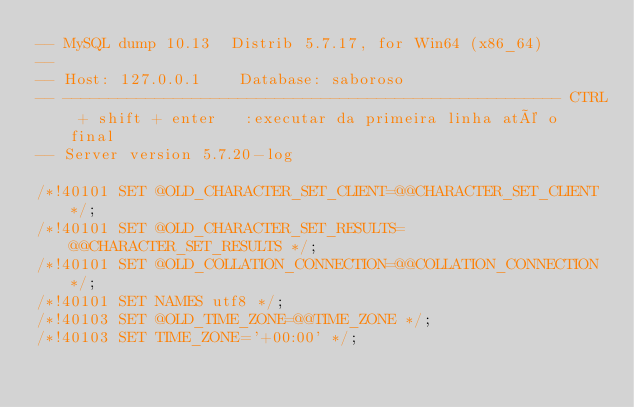Convert code to text. <code><loc_0><loc_0><loc_500><loc_500><_SQL_>-- MySQL dump 10.13  Distrib 5.7.17, for Win64 (x86_64)
--
-- Host: 127.0.0.1    Database: saboroso
-- ------------------------------------------------------ CTRL + shift + enter   :executar da primeira linha até o final
-- Server version	5.7.20-log

/*!40101 SET @OLD_CHARACTER_SET_CLIENT=@@CHARACTER_SET_CLIENT */;
/*!40101 SET @OLD_CHARACTER_SET_RESULTS=@@CHARACTER_SET_RESULTS */;
/*!40101 SET @OLD_COLLATION_CONNECTION=@@COLLATION_CONNECTION */;
/*!40101 SET NAMES utf8 */;
/*!40103 SET @OLD_TIME_ZONE=@@TIME_ZONE */;
/*!40103 SET TIME_ZONE='+00:00' */;</code> 